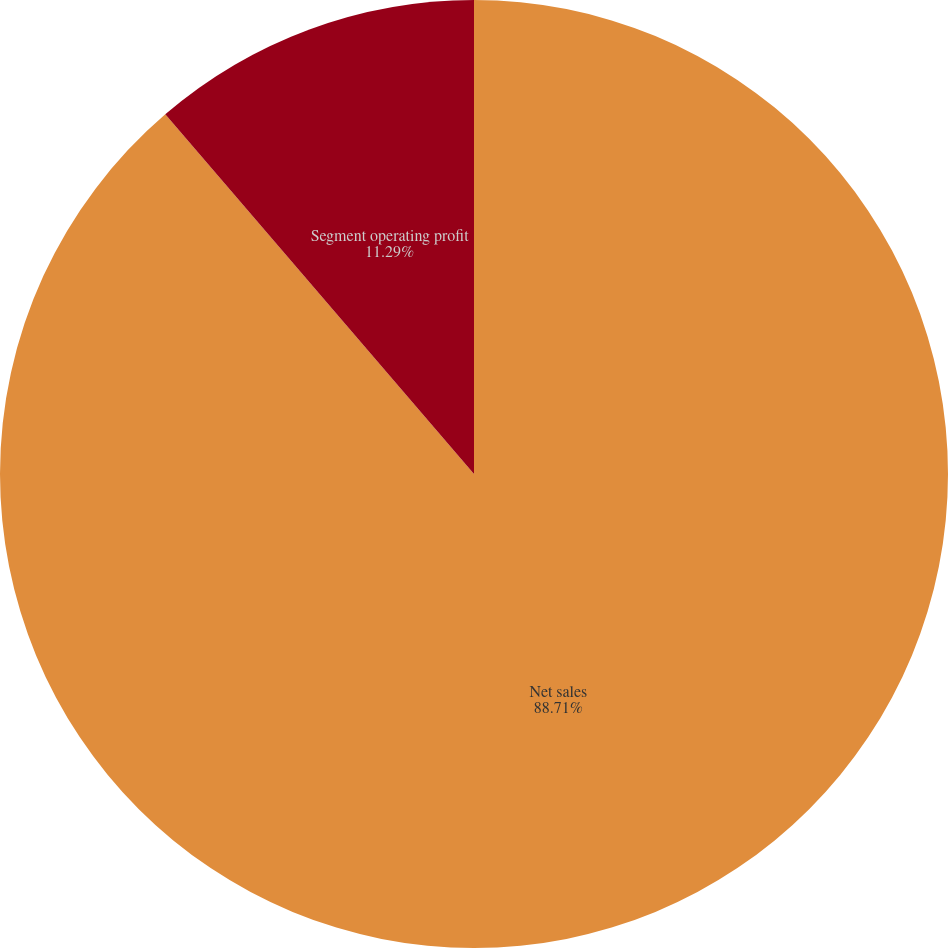Convert chart. <chart><loc_0><loc_0><loc_500><loc_500><pie_chart><fcel>Net sales<fcel>Segment operating profit<nl><fcel>88.71%<fcel>11.29%<nl></chart> 